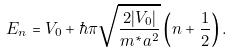<formula> <loc_0><loc_0><loc_500><loc_500>E _ { n } = V _ { 0 } + \hbar { \pi } \sqrt { \frac { 2 | V _ { 0 } | } { m ^ { * } a ^ { 2 } } } \left ( n + \frac { 1 } { 2 } \right ) .</formula> 